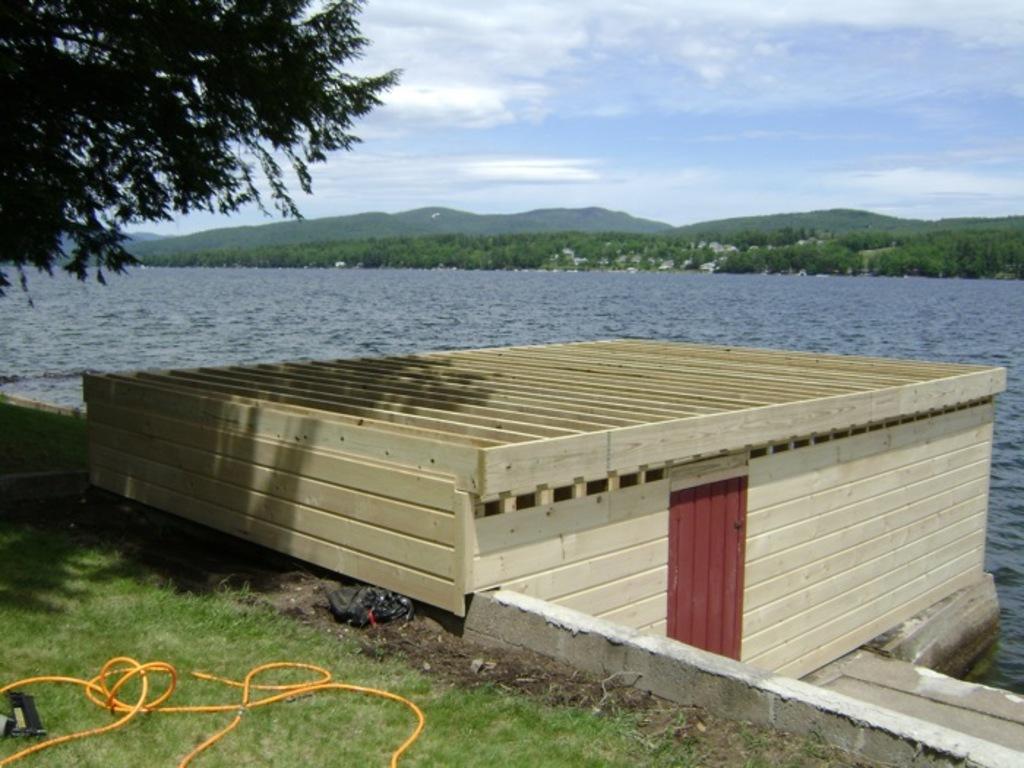Can you describe this image briefly? In this picture, we can see a house made of wooden planks, and we can see the ground, grass, water, plants, trees, mountains and the sky. 